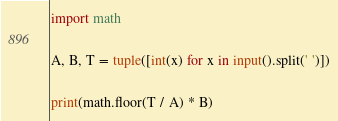Convert code to text. <code><loc_0><loc_0><loc_500><loc_500><_Python_>import math

A, B, T = tuple([int(x) for x in input().split(' ')])

print(math.floor(T / A) * B)
</code> 